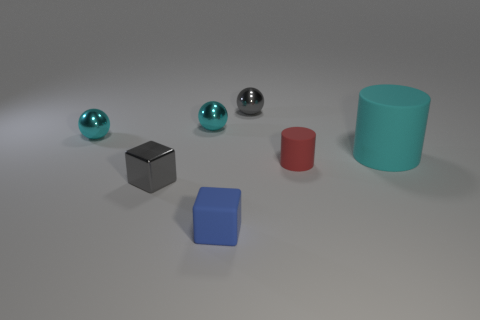Is there anything else that is the same size as the cyan rubber object?
Offer a very short reply. No. Are there the same number of tiny cyan things in front of the large cyan cylinder and metal balls right of the red rubber thing?
Your answer should be very brief. Yes. What is the small object that is on the right side of the tiny gray ball behind the tiny red cylinder made of?
Give a very brief answer. Rubber. How many things are tiny metallic things or tiny gray things that are on the left side of the blue block?
Your response must be concise. 4. The gray object that is the same material as the gray block is what size?
Make the answer very short. Small. Is the number of small rubber things right of the tiny blue block greater than the number of large blue cubes?
Provide a succinct answer. Yes. There is a object that is both right of the tiny gray metallic sphere and behind the small cylinder; what is its size?
Ensure brevity in your answer.  Large. There is another small thing that is the same shape as the blue matte object; what material is it?
Your answer should be compact. Metal. There is a gray metal object that is in front of the cyan rubber cylinder; does it have the same size as the large cylinder?
Offer a very short reply. No. The thing that is in front of the big cylinder and left of the small blue block is what color?
Keep it short and to the point. Gray. 